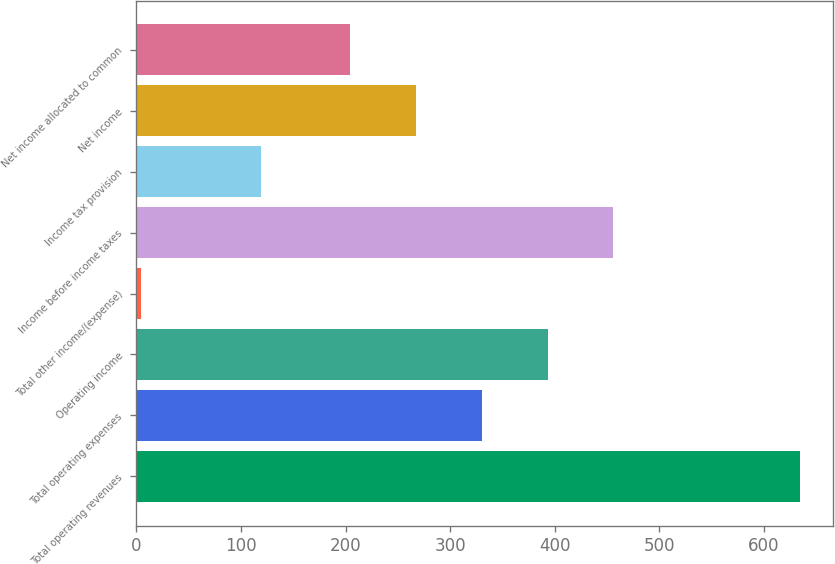Convert chart to OTSL. <chart><loc_0><loc_0><loc_500><loc_500><bar_chart><fcel>Total operating revenues<fcel>Total operating expenses<fcel>Operating income<fcel>Total other income/(expense)<fcel>Income before income taxes<fcel>Income tax provision<fcel>Net income<fcel>Net income allocated to common<nl><fcel>634.5<fcel>330.18<fcel>393.22<fcel>4.1<fcel>456.26<fcel>119<fcel>267.14<fcel>204.1<nl></chart> 